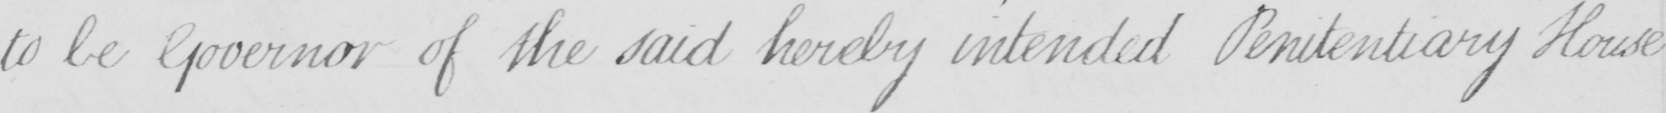Please provide the text content of this handwritten line. to be Governor of the said hereby intended Penitentiary House 